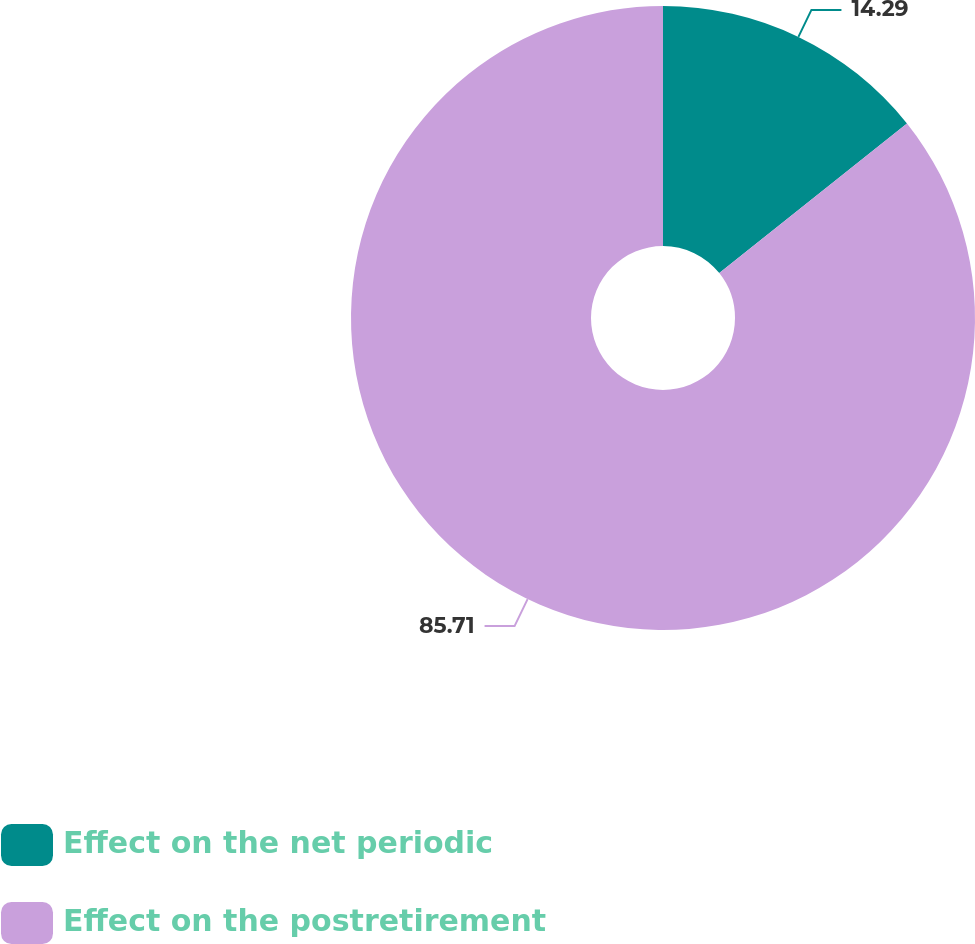Convert chart to OTSL. <chart><loc_0><loc_0><loc_500><loc_500><pie_chart><fcel>Effect on the net periodic<fcel>Effect on the postretirement<nl><fcel>14.29%<fcel>85.71%<nl></chart> 